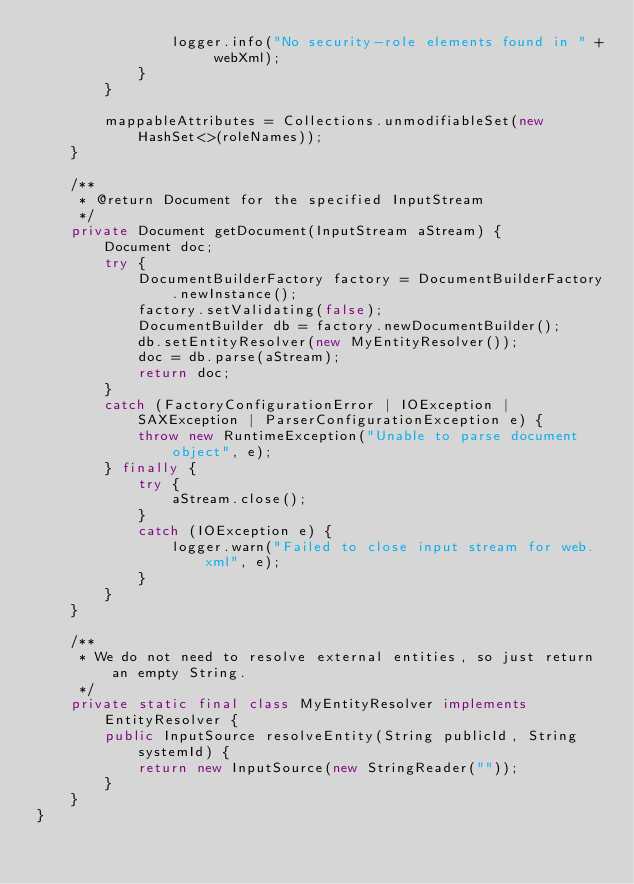<code> <loc_0><loc_0><loc_500><loc_500><_Java_>				logger.info("No security-role elements found in " + webXml);
			}
		}

		mappableAttributes = Collections.unmodifiableSet(new HashSet<>(roleNames));
	}

	/**
	 * @return Document for the specified InputStream
	 */
	private Document getDocument(InputStream aStream) {
		Document doc;
		try {
			DocumentBuilderFactory factory = DocumentBuilderFactory.newInstance();
			factory.setValidating(false);
			DocumentBuilder db = factory.newDocumentBuilder();
			db.setEntityResolver(new MyEntityResolver());
			doc = db.parse(aStream);
			return doc;
		}
		catch (FactoryConfigurationError | IOException | SAXException | ParserConfigurationException e) {
			throw new RuntimeException("Unable to parse document object", e);
		} finally {
			try {
				aStream.close();
			}
			catch (IOException e) {
				logger.warn("Failed to close input stream for web.xml", e);
			}
		}
	}

	/**
	 * We do not need to resolve external entities, so just return an empty String.
	 */
	private static final class MyEntityResolver implements EntityResolver {
		public InputSource resolveEntity(String publicId, String systemId) {
			return new InputSource(new StringReader(""));
		}
	}
}
</code> 